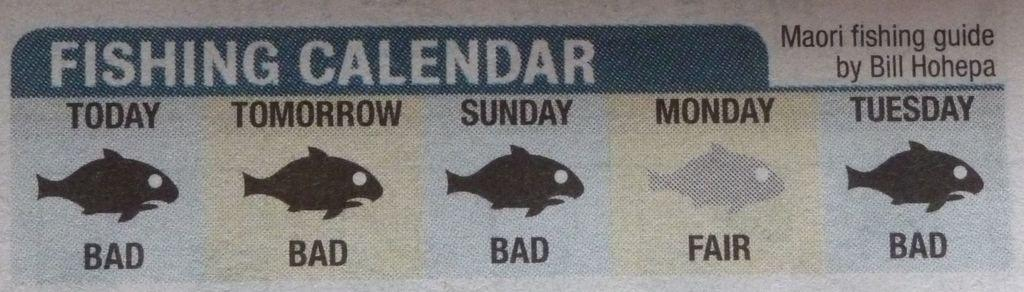What is written on the paper in the image? There is text on a paper in the image, but we cannot determine the content from the image alone. What type of images are present in the image? There are cartoon images in the image. What does the pig say to the fireman in the image? There is no pig or fireman present in the image, so this conversation cannot be observed. 